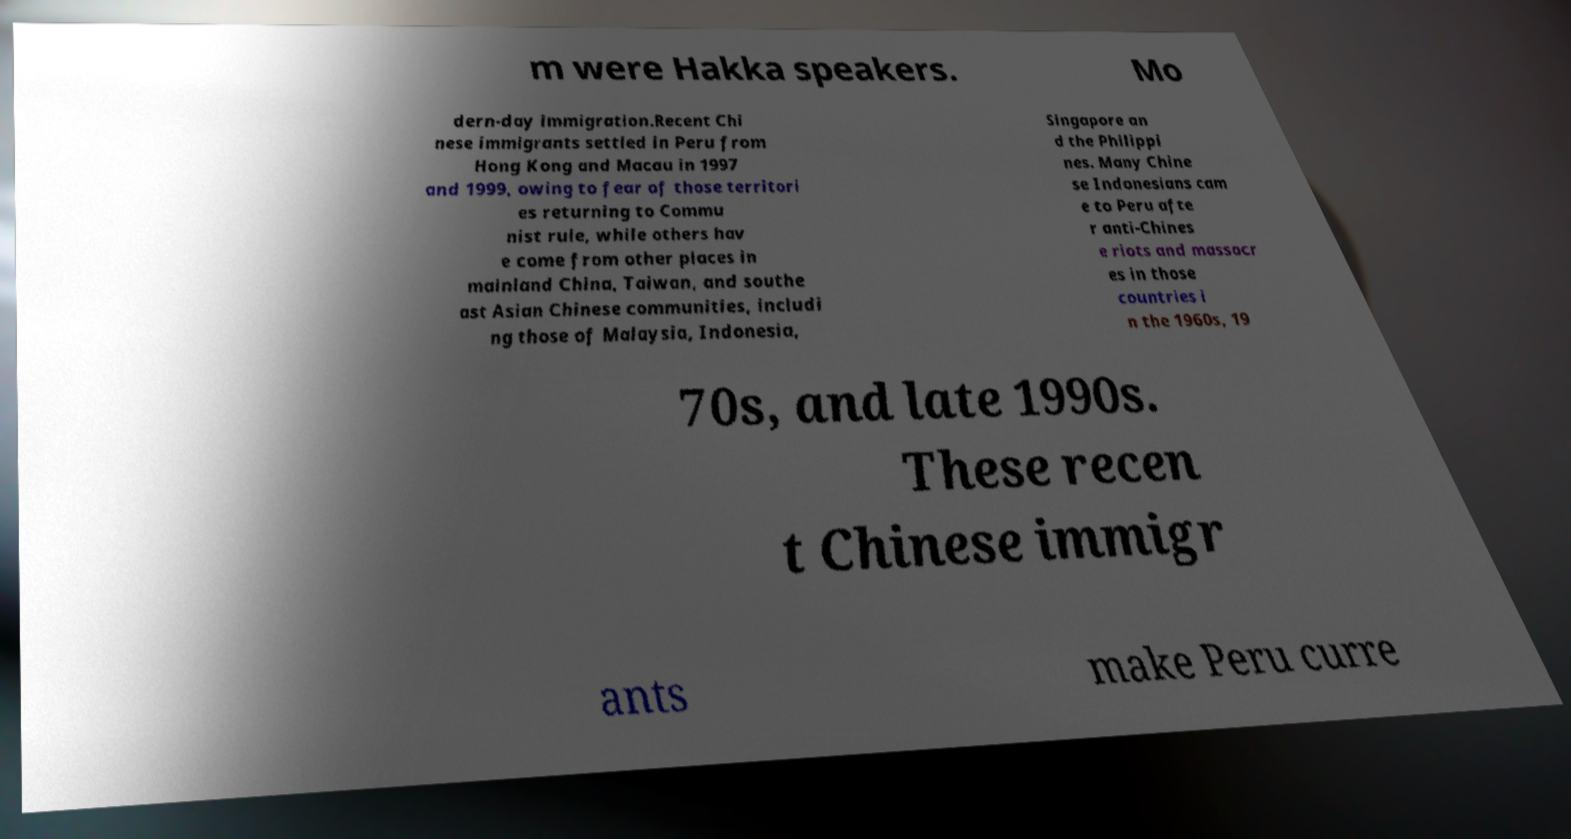Please read and relay the text visible in this image. What does it say? m were Hakka speakers. Mo dern-day immigration.Recent Chi nese immigrants settled in Peru from Hong Kong and Macau in 1997 and 1999, owing to fear of those territori es returning to Commu nist rule, while others hav e come from other places in mainland China, Taiwan, and southe ast Asian Chinese communities, includi ng those of Malaysia, Indonesia, Singapore an d the Philippi nes. Many Chine se Indonesians cam e to Peru afte r anti-Chines e riots and massacr es in those countries i n the 1960s, 19 70s, and late 1990s. These recen t Chinese immigr ants make Peru curre 